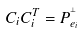Convert formula to latex. <formula><loc_0><loc_0><loc_500><loc_500>C _ { i } C _ { i } ^ { T } = P _ { e _ { i } } ^ { ^ { \perp } }</formula> 